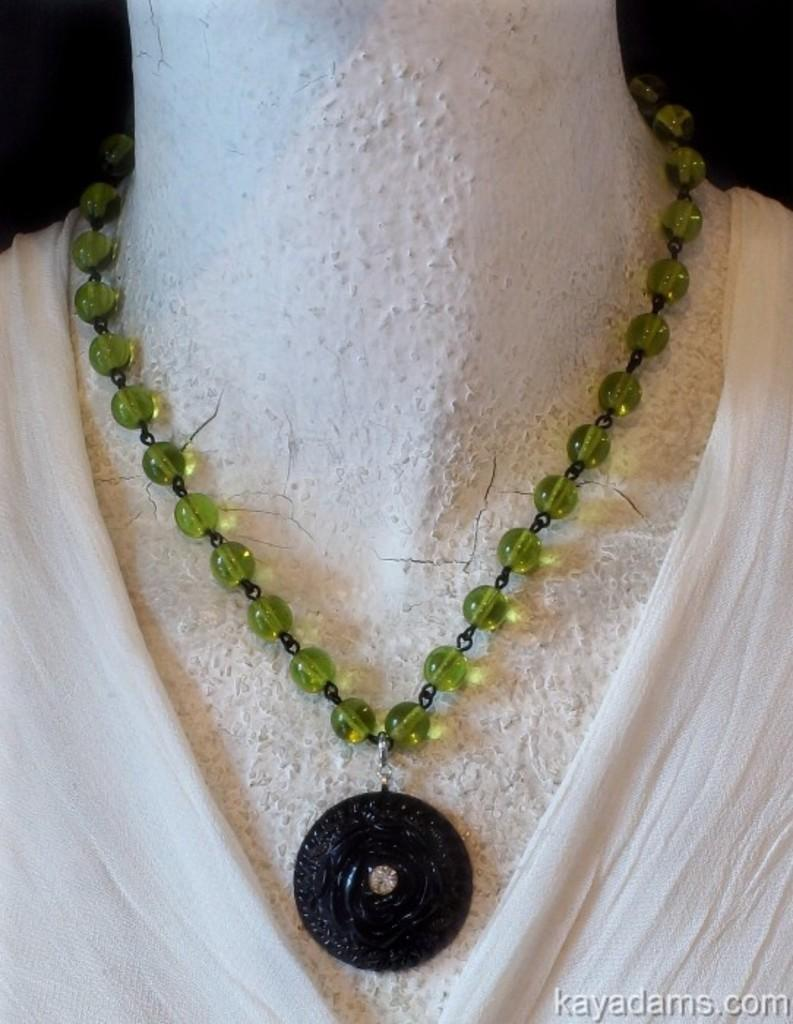What is the main object in the image? There is a chain in the image. What is attached to the chain? There is a pendant in the image, and it is attached to the chain. What other object is present in the image? There is a doll in the image. How is the chain related to the doll? The chain is attached to the doll. What type of train can be seen in the image? There is no train present in the image. How does the guitar contribute to the image? There is no guitar present in the image. 